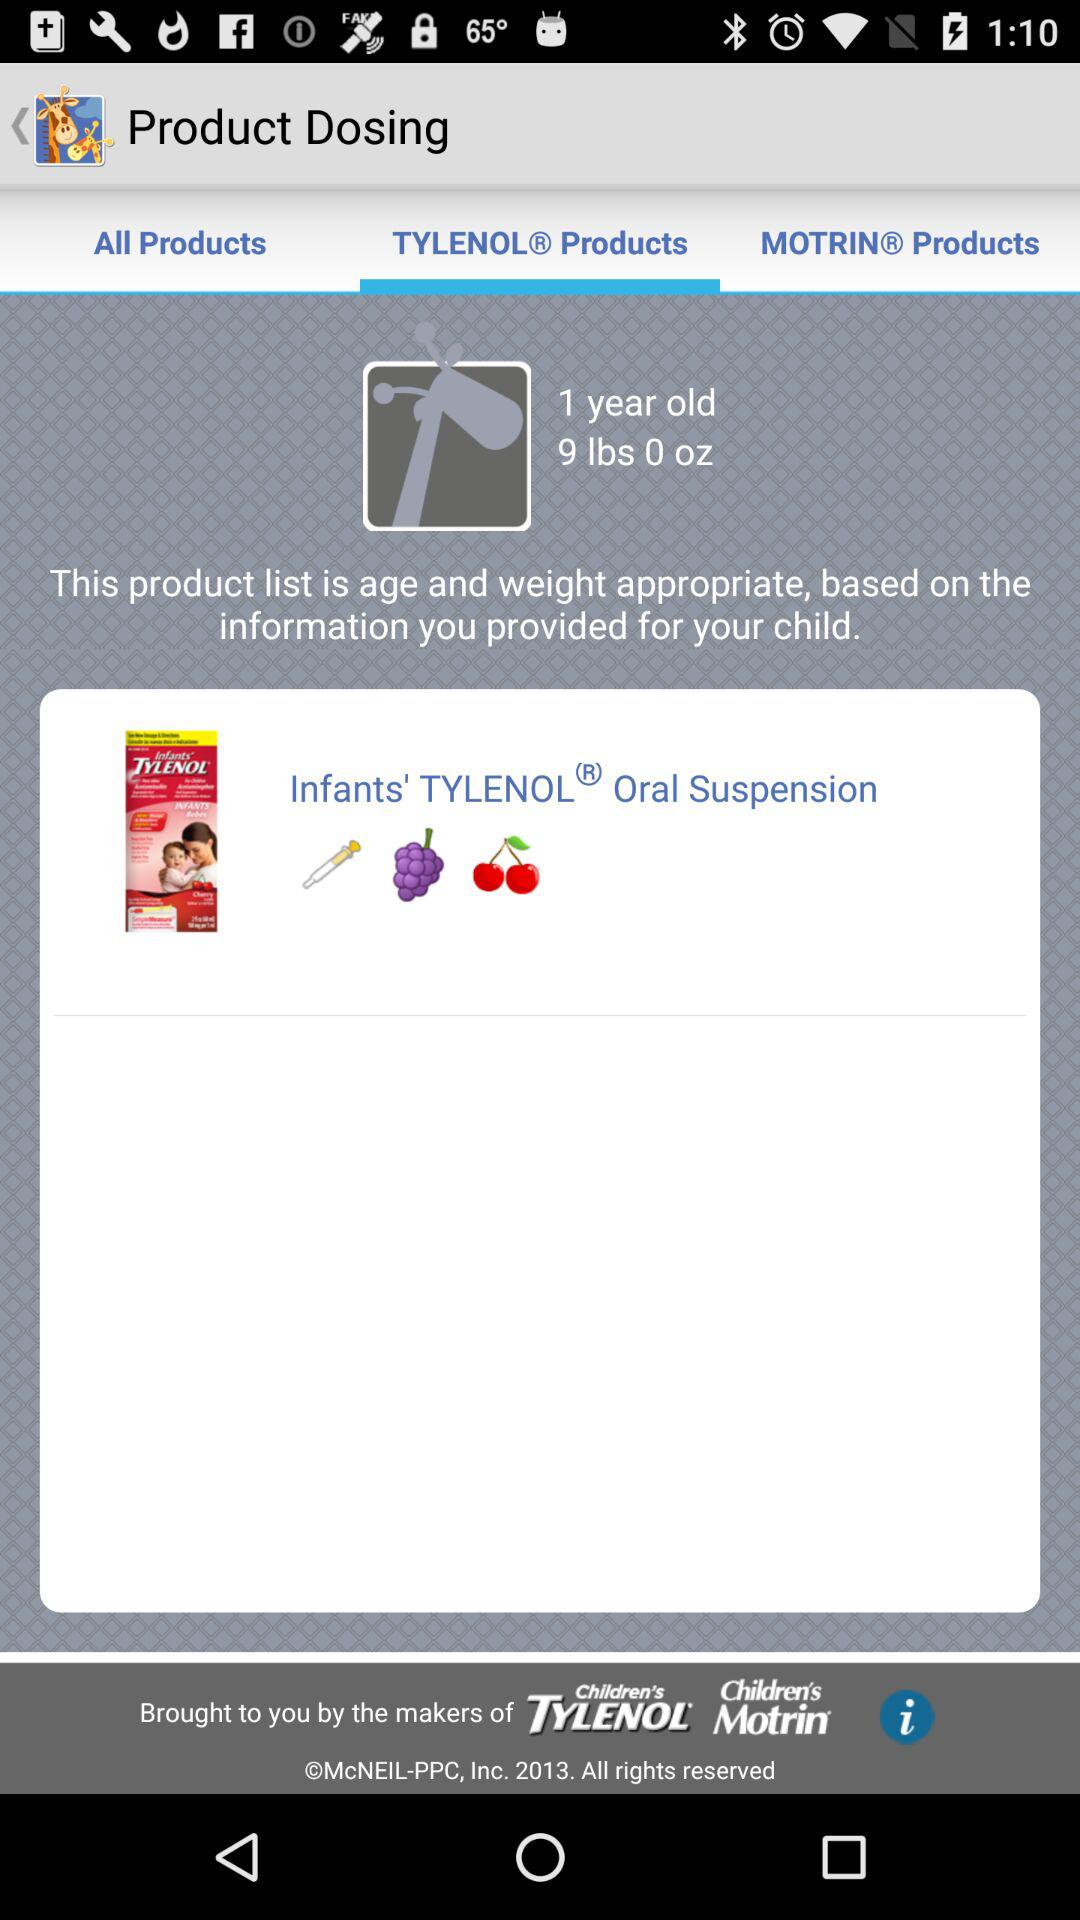What is the weight of the child? The weight of the child is 9 lbs. 